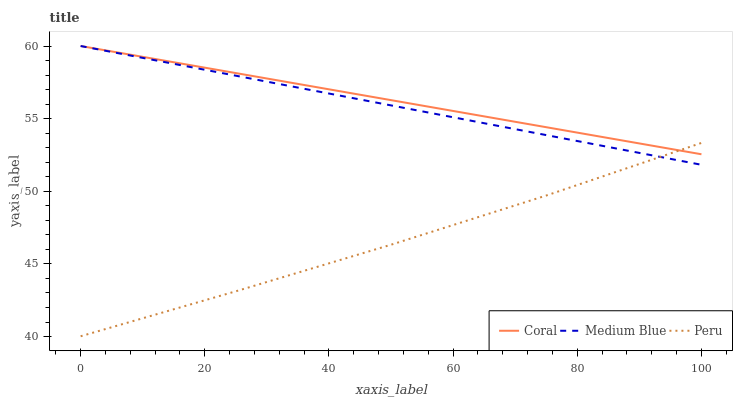Does Peru have the minimum area under the curve?
Answer yes or no. Yes. Does Coral have the maximum area under the curve?
Answer yes or no. Yes. Does Medium Blue have the minimum area under the curve?
Answer yes or no. No. Does Medium Blue have the maximum area under the curve?
Answer yes or no. No. Is Coral the smoothest?
Answer yes or no. Yes. Is Peru the roughest?
Answer yes or no. Yes. Is Medium Blue the smoothest?
Answer yes or no. No. Is Medium Blue the roughest?
Answer yes or no. No. Does Peru have the lowest value?
Answer yes or no. Yes. Does Medium Blue have the lowest value?
Answer yes or no. No. Does Medium Blue have the highest value?
Answer yes or no. Yes. Does Peru have the highest value?
Answer yes or no. No. Does Peru intersect Coral?
Answer yes or no. Yes. Is Peru less than Coral?
Answer yes or no. No. Is Peru greater than Coral?
Answer yes or no. No. 